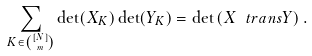Convert formula to latex. <formula><loc_0><loc_0><loc_500><loc_500>\sum _ { K \in \binom { [ N ] } { m } } \det ( X _ { K } ) \det ( Y _ { K } ) = \det \left ( X \ t r a n s Y \right ) .</formula> 